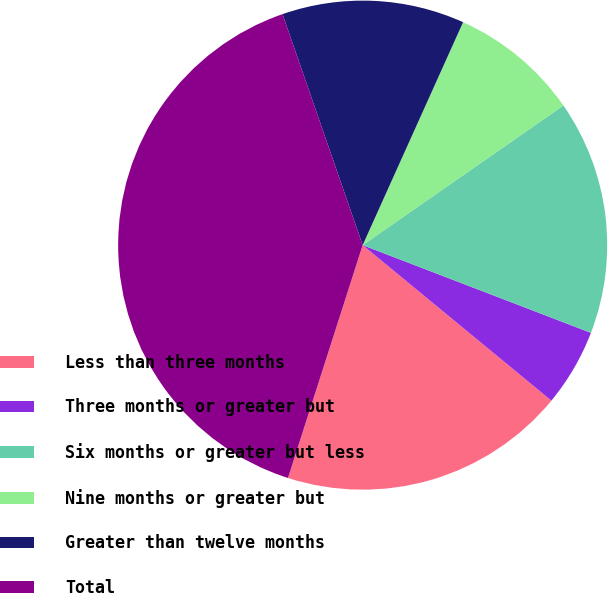Convert chart to OTSL. <chart><loc_0><loc_0><loc_500><loc_500><pie_chart><fcel>Less than three months<fcel>Three months or greater but<fcel>Six months or greater but less<fcel>Nine months or greater but<fcel>Greater than twelve months<fcel>Total<nl><fcel>18.97%<fcel>5.13%<fcel>15.51%<fcel>8.59%<fcel>12.05%<fcel>39.74%<nl></chart> 